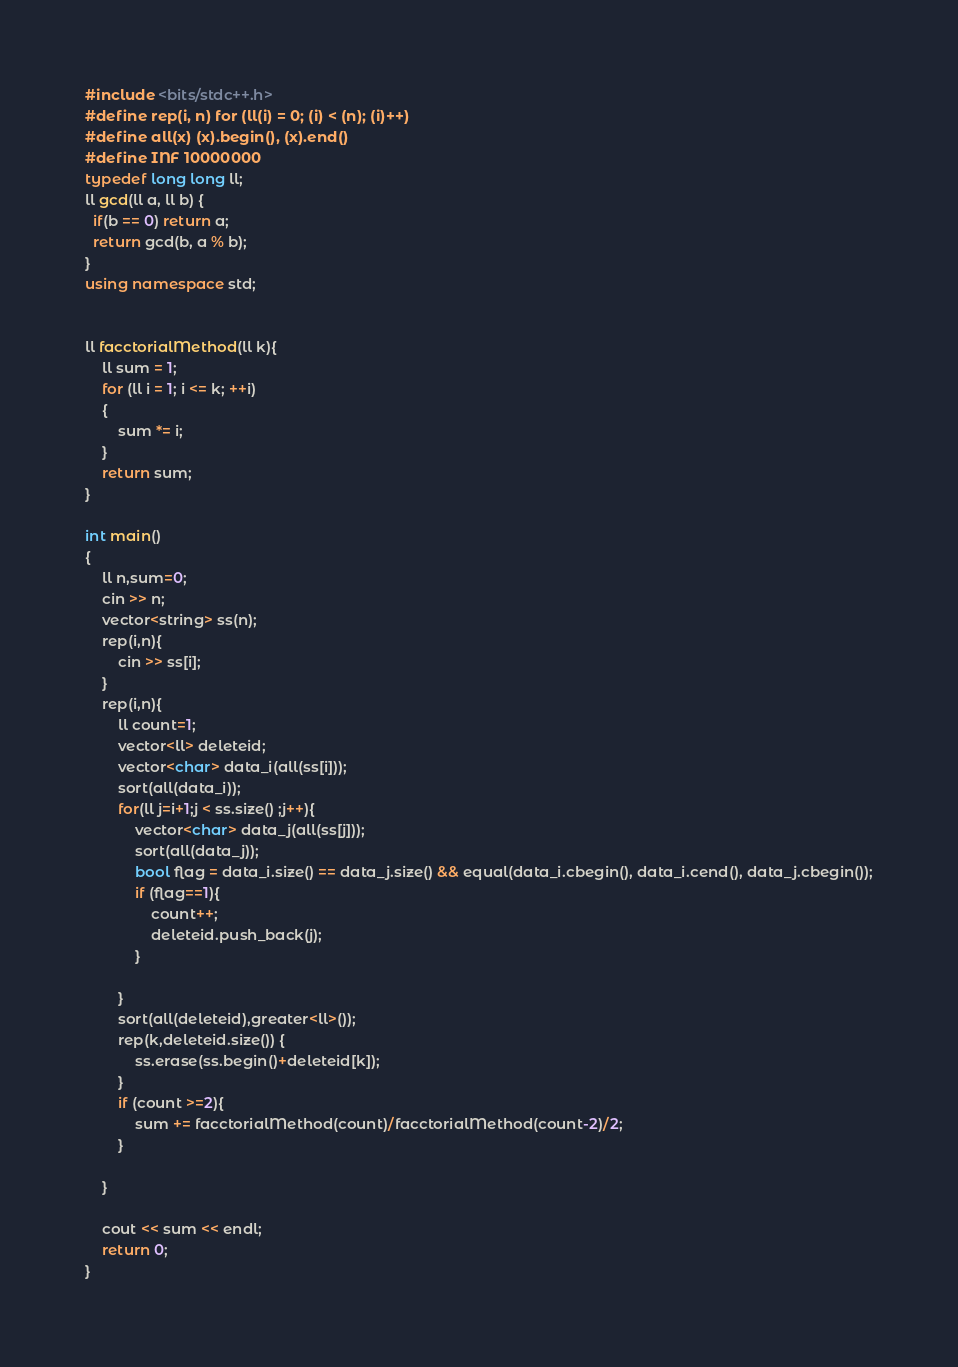<code> <loc_0><loc_0><loc_500><loc_500><_C++_>#include <bits/stdc++.h>
#define rep(i, n) for (ll(i) = 0; (i) < (n); (i)++)
#define all(x) (x).begin(), (x).end()
#define INF 10000000
typedef long long ll;
ll gcd(ll a, ll b) {
  if(b == 0) return a;
  return gcd(b, a % b);
}
using namespace std;


ll facctorialMethod(ll k){
    ll sum = 1;
    for (ll i = 1; i <= k; ++i)
    {
        sum *= i;
    }
    return sum;
}

int main()
{
    ll n,sum=0;
    cin >> n;
    vector<string> ss(n);
    rep(i,n){
        cin >> ss[i];
    }
    rep(i,n){
        ll count=1;
        vector<ll> deleteid;
        vector<char> data_i(all(ss[i]));
        sort(all(data_i));
        for(ll j=i+1;j < ss.size() ;j++){
            vector<char> data_j(all(ss[j]));
            sort(all(data_j));
            bool flag = data_i.size() == data_j.size() && equal(data_i.cbegin(), data_i.cend(), data_j.cbegin());
            if (flag==1){
                count++;
                deleteid.push_back(j);
            }
                
        }
        sort(all(deleteid),greater<ll>());
        rep(k,deleteid.size()) {
            ss.erase(ss.begin()+deleteid[k]);
        } 
        if (count >=2){
            sum += facctorialMethod(count)/facctorialMethod(count-2)/2;
        }

    }
    
    cout << sum << endl;
    return 0;
}</code> 